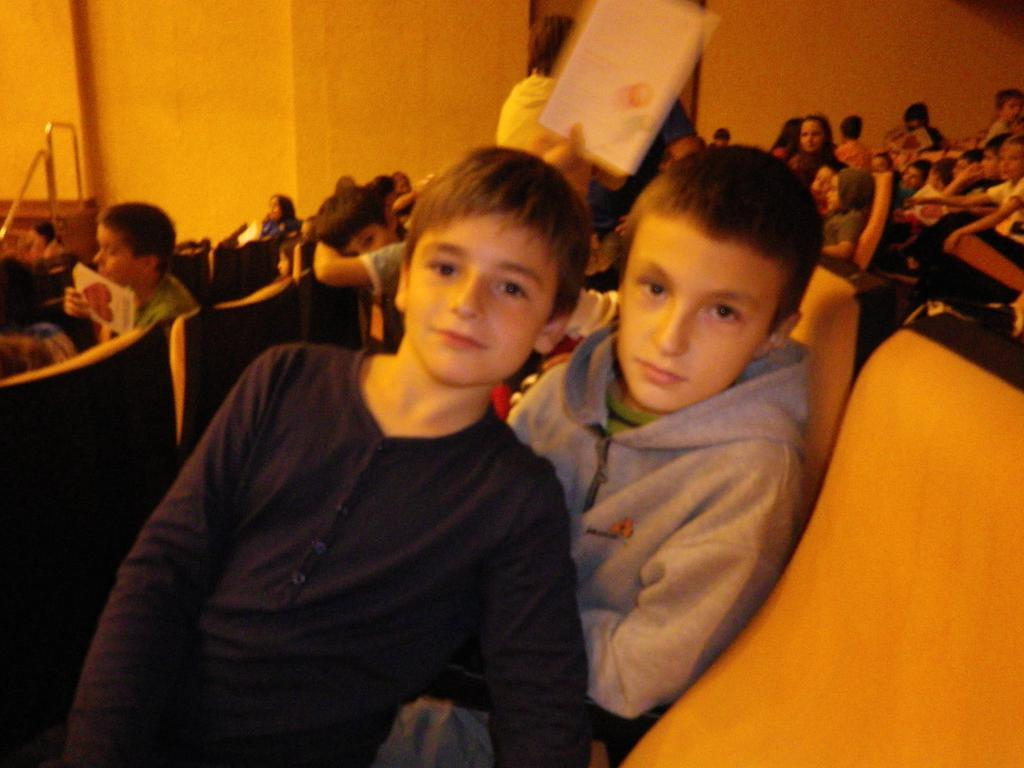What is happening in the foreground of the image? There is a group of people in the foreground of the image. What are the people doing in the image? The people are sitting on chairs. What can be seen in the background of the image? There is a wall and metal rods in the background of the image. What type of location might the image be taken in? The image is likely taken in a hall. What language is being spoken by the people in the image? There is no information about the language being spoken in the image. How many sheets of paper are visible in the image? There is no paper visible in the image. 